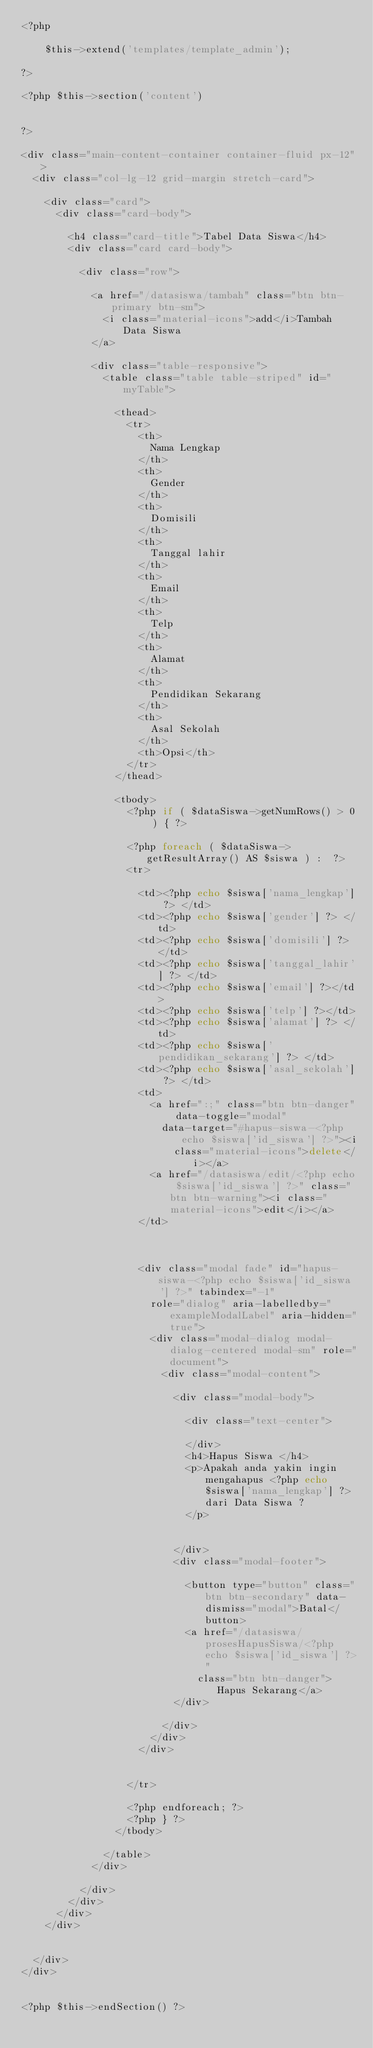<code> <loc_0><loc_0><loc_500><loc_500><_PHP_><?php

    $this->extend('templates/template_admin');

?>

<?php $this->section('content') 


?>

<div class="main-content-container container-fluid px-12">
  <div class="col-lg-12 grid-margin stretch-card">

    <div class="card">
      <div class="card-body">

        <h4 class="card-title">Tabel Data Siswa</h4>
        <div class="card card-body">

          <div class="row">

            <a href="/datasiswa/tambah" class="btn btn-primary btn-sm">
              <i class="material-icons">add</i>Tambah Data Siswa
            </a>

            <div class="table-responsive">
              <table class="table table-striped" id="myTable">

                <thead>
                  <tr>
                    <th>
                      Nama Lengkap
                    </th>
                    <th>
                      Gender
                    </th>
                    <th>
                      Domisili
                    </th>
                    <th>
                      Tanggal lahir
                    </th>
                    <th>
                      Email
                    </th>
                    <th>
                      Telp
                    </th>
                    <th>
                      Alamat
                    </th>
                    <th>
                      Pendidikan Sekarang
                    </th>
                    <th>
                      Asal Sekolah
                    </th>
                    <th>Opsi</th>
                  </tr>
                </thead>

                <tbody>
                  <?php if ( $dataSiswa->getNumRows() > 0 ) { ?>

                  <?php foreach ( $dataSiswa->getResultArray() AS $siswa ) :  ?>
                  <tr>

                    <td><?php echo $siswa['nama_lengkap'] ?> </td>
                    <td><?php echo $siswa['gender'] ?> </td>
                    <td><?php echo $siswa['domisili'] ?> </td>
                    <td><?php echo $siswa['tanggal_lahir'] ?> </td>
                    <td><?php echo $siswa['email'] ?></td>
                    <td><?php echo $siswa['telp'] ?></td>
                    <td><?php echo $siswa['alamat'] ?> </td>
                    <td><?php echo $siswa['pendidikan_sekarang'] ?> </td>
                    <td><?php echo $siswa['asal_sekolah'] ?> </td>
                    <td>
                      <a href=":;" class="btn btn-danger" data-toggle="modal"
                        data-target="#hapus-siswa-<?php echo $siswa['id_siswa'] ?>"><i
                          class="material-icons">delete</i></a>
                      <a href="/datasiswa/edit/<?php echo $siswa['id_siswa'] ?>" class="btn btn-warning"><i class="material-icons">edit</i></a>
                    </td>



                    <div class="modal fade" id="hapus-siswa-<?php echo $siswa['id_siswa'] ?>" tabindex="-1"
                      role="dialog" aria-labelledby="exampleModalLabel" aria-hidden="true">
                      <div class="modal-dialog modal-dialog-centered modal-sm" role="document">
                        <div class="modal-content">

                          <div class="modal-body">

                            <div class="text-center">

                            </div>
                            <h4>Hapus Siswa </h4>
                            <p>Apakah anda yakin ingin mengahapus <?php echo $siswa['nama_lengkap'] ?> dari Data Siswa ?
                            </p>


                          </div>
                          <div class="modal-footer">

                            <button type="button" class="btn btn-secondary" data-dismiss="modal">Batal</button>
                            <a href="/datasiswa/prosesHapusSiswa/<?php echo $siswa['id_siswa'] ?>"
                              class="btn btn-danger">Hapus Sekarang</a>
                          </div>

                        </div>
                      </div>
                    </div>


                  </tr>

                  <?php endforeach; ?>
                  <?php } ?>
                </tbody>

              </table>
            </div>

          </div>
        </div>
      </div>
    </div>


  </div>
</div>


<?php $this->endSection() ?></code> 